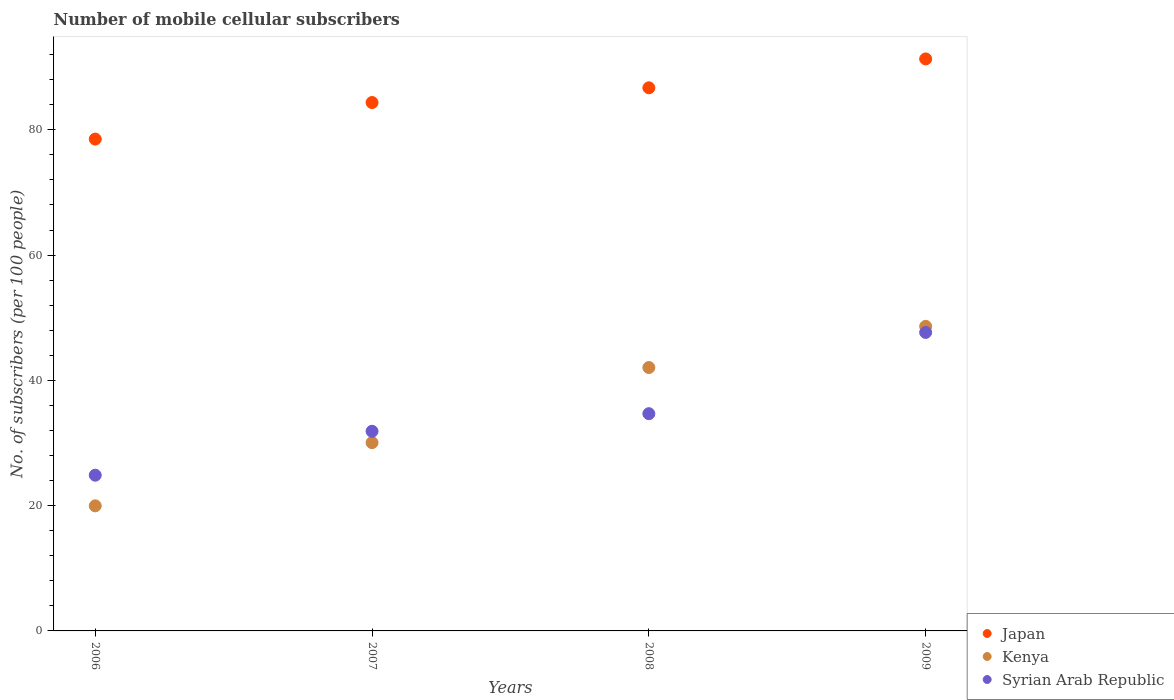Is the number of dotlines equal to the number of legend labels?
Make the answer very short. Yes. What is the number of mobile cellular subscribers in Syrian Arab Republic in 2007?
Make the answer very short. 31.87. Across all years, what is the maximum number of mobile cellular subscribers in Kenya?
Your response must be concise. 48.62. Across all years, what is the minimum number of mobile cellular subscribers in Syrian Arab Republic?
Ensure brevity in your answer.  24.86. In which year was the number of mobile cellular subscribers in Syrian Arab Republic maximum?
Your response must be concise. 2009. What is the total number of mobile cellular subscribers in Kenya in the graph?
Your answer should be compact. 140.71. What is the difference between the number of mobile cellular subscribers in Syrian Arab Republic in 2008 and that in 2009?
Your response must be concise. -12.97. What is the difference between the number of mobile cellular subscribers in Kenya in 2007 and the number of mobile cellular subscribers in Syrian Arab Republic in 2008?
Your answer should be compact. -4.62. What is the average number of mobile cellular subscribers in Japan per year?
Offer a very short reply. 85.22. In the year 2006, what is the difference between the number of mobile cellular subscribers in Kenya and number of mobile cellular subscribers in Japan?
Offer a very short reply. -58.55. What is the ratio of the number of mobile cellular subscribers in Kenya in 2006 to that in 2009?
Provide a short and direct response. 0.41. What is the difference between the highest and the second highest number of mobile cellular subscribers in Kenya?
Your answer should be compact. 6.58. What is the difference between the highest and the lowest number of mobile cellular subscribers in Japan?
Provide a short and direct response. 12.8. Is the sum of the number of mobile cellular subscribers in Kenya in 2006 and 2007 greater than the maximum number of mobile cellular subscribers in Syrian Arab Republic across all years?
Your answer should be compact. Yes. Is the number of mobile cellular subscribers in Syrian Arab Republic strictly greater than the number of mobile cellular subscribers in Kenya over the years?
Ensure brevity in your answer.  No. Is the number of mobile cellular subscribers in Japan strictly less than the number of mobile cellular subscribers in Syrian Arab Republic over the years?
Provide a short and direct response. No. How many dotlines are there?
Ensure brevity in your answer.  3. What is the difference between two consecutive major ticks on the Y-axis?
Give a very brief answer. 20. Are the values on the major ticks of Y-axis written in scientific E-notation?
Provide a succinct answer. No. Does the graph contain any zero values?
Keep it short and to the point. No. Does the graph contain grids?
Your answer should be very brief. No. Where does the legend appear in the graph?
Your answer should be very brief. Bottom right. What is the title of the graph?
Make the answer very short. Number of mobile cellular subscribers. What is the label or title of the Y-axis?
Keep it short and to the point. No. of subscribers (per 100 people). What is the No. of subscribers (per 100 people) of Japan in 2006?
Provide a succinct answer. 78.52. What is the No. of subscribers (per 100 people) of Kenya in 2006?
Ensure brevity in your answer.  19.97. What is the No. of subscribers (per 100 people) in Syrian Arab Republic in 2006?
Make the answer very short. 24.86. What is the No. of subscribers (per 100 people) in Japan in 2007?
Your answer should be very brief. 84.35. What is the No. of subscribers (per 100 people) in Kenya in 2007?
Offer a very short reply. 30.06. What is the No. of subscribers (per 100 people) in Syrian Arab Republic in 2007?
Your response must be concise. 31.87. What is the No. of subscribers (per 100 people) in Japan in 2008?
Offer a very short reply. 86.71. What is the No. of subscribers (per 100 people) in Kenya in 2008?
Provide a short and direct response. 42.05. What is the No. of subscribers (per 100 people) in Syrian Arab Republic in 2008?
Provide a succinct answer. 34.68. What is the No. of subscribers (per 100 people) of Japan in 2009?
Keep it short and to the point. 91.32. What is the No. of subscribers (per 100 people) of Kenya in 2009?
Give a very brief answer. 48.62. What is the No. of subscribers (per 100 people) of Syrian Arab Republic in 2009?
Your response must be concise. 47.65. Across all years, what is the maximum No. of subscribers (per 100 people) in Japan?
Offer a terse response. 91.32. Across all years, what is the maximum No. of subscribers (per 100 people) in Kenya?
Your answer should be very brief. 48.62. Across all years, what is the maximum No. of subscribers (per 100 people) of Syrian Arab Republic?
Keep it short and to the point. 47.65. Across all years, what is the minimum No. of subscribers (per 100 people) of Japan?
Make the answer very short. 78.52. Across all years, what is the minimum No. of subscribers (per 100 people) of Kenya?
Your answer should be very brief. 19.97. Across all years, what is the minimum No. of subscribers (per 100 people) of Syrian Arab Republic?
Your answer should be compact. 24.86. What is the total No. of subscribers (per 100 people) in Japan in the graph?
Your response must be concise. 340.9. What is the total No. of subscribers (per 100 people) of Kenya in the graph?
Ensure brevity in your answer.  140.71. What is the total No. of subscribers (per 100 people) of Syrian Arab Republic in the graph?
Ensure brevity in your answer.  139.07. What is the difference between the No. of subscribers (per 100 people) in Japan in 2006 and that in 2007?
Your answer should be very brief. -5.83. What is the difference between the No. of subscribers (per 100 people) of Kenya in 2006 and that in 2007?
Ensure brevity in your answer.  -10.09. What is the difference between the No. of subscribers (per 100 people) of Syrian Arab Republic in 2006 and that in 2007?
Keep it short and to the point. -7.01. What is the difference between the No. of subscribers (per 100 people) of Japan in 2006 and that in 2008?
Ensure brevity in your answer.  -8.19. What is the difference between the No. of subscribers (per 100 people) of Kenya in 2006 and that in 2008?
Keep it short and to the point. -22.08. What is the difference between the No. of subscribers (per 100 people) in Syrian Arab Republic in 2006 and that in 2008?
Your answer should be compact. -9.82. What is the difference between the No. of subscribers (per 100 people) in Japan in 2006 and that in 2009?
Offer a terse response. -12.8. What is the difference between the No. of subscribers (per 100 people) in Kenya in 2006 and that in 2009?
Give a very brief answer. -28.65. What is the difference between the No. of subscribers (per 100 people) of Syrian Arab Republic in 2006 and that in 2009?
Provide a succinct answer. -22.79. What is the difference between the No. of subscribers (per 100 people) in Japan in 2007 and that in 2008?
Give a very brief answer. -2.35. What is the difference between the No. of subscribers (per 100 people) of Kenya in 2007 and that in 2008?
Your answer should be compact. -11.99. What is the difference between the No. of subscribers (per 100 people) in Syrian Arab Republic in 2007 and that in 2008?
Ensure brevity in your answer.  -2.81. What is the difference between the No. of subscribers (per 100 people) in Japan in 2007 and that in 2009?
Your answer should be very brief. -6.96. What is the difference between the No. of subscribers (per 100 people) in Kenya in 2007 and that in 2009?
Make the answer very short. -18.56. What is the difference between the No. of subscribers (per 100 people) in Syrian Arab Republic in 2007 and that in 2009?
Keep it short and to the point. -15.78. What is the difference between the No. of subscribers (per 100 people) in Japan in 2008 and that in 2009?
Offer a very short reply. -4.61. What is the difference between the No. of subscribers (per 100 people) in Kenya in 2008 and that in 2009?
Provide a short and direct response. -6.58. What is the difference between the No. of subscribers (per 100 people) of Syrian Arab Republic in 2008 and that in 2009?
Your response must be concise. -12.97. What is the difference between the No. of subscribers (per 100 people) in Japan in 2006 and the No. of subscribers (per 100 people) in Kenya in 2007?
Offer a very short reply. 48.46. What is the difference between the No. of subscribers (per 100 people) of Japan in 2006 and the No. of subscribers (per 100 people) of Syrian Arab Republic in 2007?
Keep it short and to the point. 46.65. What is the difference between the No. of subscribers (per 100 people) in Kenya in 2006 and the No. of subscribers (per 100 people) in Syrian Arab Republic in 2007?
Make the answer very short. -11.9. What is the difference between the No. of subscribers (per 100 people) in Japan in 2006 and the No. of subscribers (per 100 people) in Kenya in 2008?
Provide a short and direct response. 36.47. What is the difference between the No. of subscribers (per 100 people) of Japan in 2006 and the No. of subscribers (per 100 people) of Syrian Arab Republic in 2008?
Your answer should be compact. 43.84. What is the difference between the No. of subscribers (per 100 people) of Kenya in 2006 and the No. of subscribers (per 100 people) of Syrian Arab Republic in 2008?
Give a very brief answer. -14.71. What is the difference between the No. of subscribers (per 100 people) of Japan in 2006 and the No. of subscribers (per 100 people) of Kenya in 2009?
Provide a succinct answer. 29.89. What is the difference between the No. of subscribers (per 100 people) in Japan in 2006 and the No. of subscribers (per 100 people) in Syrian Arab Republic in 2009?
Keep it short and to the point. 30.87. What is the difference between the No. of subscribers (per 100 people) in Kenya in 2006 and the No. of subscribers (per 100 people) in Syrian Arab Republic in 2009?
Offer a very short reply. -27.68. What is the difference between the No. of subscribers (per 100 people) of Japan in 2007 and the No. of subscribers (per 100 people) of Kenya in 2008?
Offer a very short reply. 42.31. What is the difference between the No. of subscribers (per 100 people) of Japan in 2007 and the No. of subscribers (per 100 people) of Syrian Arab Republic in 2008?
Provide a succinct answer. 49.67. What is the difference between the No. of subscribers (per 100 people) in Kenya in 2007 and the No. of subscribers (per 100 people) in Syrian Arab Republic in 2008?
Offer a very short reply. -4.62. What is the difference between the No. of subscribers (per 100 people) in Japan in 2007 and the No. of subscribers (per 100 people) in Kenya in 2009?
Make the answer very short. 35.73. What is the difference between the No. of subscribers (per 100 people) of Japan in 2007 and the No. of subscribers (per 100 people) of Syrian Arab Republic in 2009?
Your response must be concise. 36.7. What is the difference between the No. of subscribers (per 100 people) of Kenya in 2007 and the No. of subscribers (per 100 people) of Syrian Arab Republic in 2009?
Offer a terse response. -17.59. What is the difference between the No. of subscribers (per 100 people) in Japan in 2008 and the No. of subscribers (per 100 people) in Kenya in 2009?
Your answer should be very brief. 38.08. What is the difference between the No. of subscribers (per 100 people) of Japan in 2008 and the No. of subscribers (per 100 people) of Syrian Arab Republic in 2009?
Give a very brief answer. 39.06. What is the difference between the No. of subscribers (per 100 people) in Kenya in 2008 and the No. of subscribers (per 100 people) in Syrian Arab Republic in 2009?
Your answer should be very brief. -5.6. What is the average No. of subscribers (per 100 people) in Japan per year?
Provide a succinct answer. 85.22. What is the average No. of subscribers (per 100 people) in Kenya per year?
Your answer should be compact. 35.18. What is the average No. of subscribers (per 100 people) in Syrian Arab Republic per year?
Provide a succinct answer. 34.77. In the year 2006, what is the difference between the No. of subscribers (per 100 people) of Japan and No. of subscribers (per 100 people) of Kenya?
Give a very brief answer. 58.55. In the year 2006, what is the difference between the No. of subscribers (per 100 people) in Japan and No. of subscribers (per 100 people) in Syrian Arab Republic?
Your answer should be very brief. 53.66. In the year 2006, what is the difference between the No. of subscribers (per 100 people) in Kenya and No. of subscribers (per 100 people) in Syrian Arab Republic?
Your answer should be very brief. -4.89. In the year 2007, what is the difference between the No. of subscribers (per 100 people) of Japan and No. of subscribers (per 100 people) of Kenya?
Your response must be concise. 54.29. In the year 2007, what is the difference between the No. of subscribers (per 100 people) in Japan and No. of subscribers (per 100 people) in Syrian Arab Republic?
Give a very brief answer. 52.48. In the year 2007, what is the difference between the No. of subscribers (per 100 people) of Kenya and No. of subscribers (per 100 people) of Syrian Arab Republic?
Offer a very short reply. -1.81. In the year 2008, what is the difference between the No. of subscribers (per 100 people) of Japan and No. of subscribers (per 100 people) of Kenya?
Your response must be concise. 44.66. In the year 2008, what is the difference between the No. of subscribers (per 100 people) of Japan and No. of subscribers (per 100 people) of Syrian Arab Republic?
Your response must be concise. 52.03. In the year 2008, what is the difference between the No. of subscribers (per 100 people) of Kenya and No. of subscribers (per 100 people) of Syrian Arab Republic?
Provide a short and direct response. 7.37. In the year 2009, what is the difference between the No. of subscribers (per 100 people) of Japan and No. of subscribers (per 100 people) of Kenya?
Offer a very short reply. 42.69. In the year 2009, what is the difference between the No. of subscribers (per 100 people) of Japan and No. of subscribers (per 100 people) of Syrian Arab Republic?
Offer a very short reply. 43.67. In the year 2009, what is the difference between the No. of subscribers (per 100 people) in Kenya and No. of subscribers (per 100 people) in Syrian Arab Republic?
Offer a very short reply. 0.97. What is the ratio of the No. of subscribers (per 100 people) of Japan in 2006 to that in 2007?
Your answer should be very brief. 0.93. What is the ratio of the No. of subscribers (per 100 people) in Kenya in 2006 to that in 2007?
Make the answer very short. 0.66. What is the ratio of the No. of subscribers (per 100 people) in Syrian Arab Republic in 2006 to that in 2007?
Offer a very short reply. 0.78. What is the ratio of the No. of subscribers (per 100 people) in Japan in 2006 to that in 2008?
Give a very brief answer. 0.91. What is the ratio of the No. of subscribers (per 100 people) of Kenya in 2006 to that in 2008?
Keep it short and to the point. 0.47. What is the ratio of the No. of subscribers (per 100 people) in Syrian Arab Republic in 2006 to that in 2008?
Your answer should be very brief. 0.72. What is the ratio of the No. of subscribers (per 100 people) in Japan in 2006 to that in 2009?
Offer a terse response. 0.86. What is the ratio of the No. of subscribers (per 100 people) in Kenya in 2006 to that in 2009?
Keep it short and to the point. 0.41. What is the ratio of the No. of subscribers (per 100 people) in Syrian Arab Republic in 2006 to that in 2009?
Provide a succinct answer. 0.52. What is the ratio of the No. of subscribers (per 100 people) in Japan in 2007 to that in 2008?
Offer a terse response. 0.97. What is the ratio of the No. of subscribers (per 100 people) in Kenya in 2007 to that in 2008?
Ensure brevity in your answer.  0.71. What is the ratio of the No. of subscribers (per 100 people) in Syrian Arab Republic in 2007 to that in 2008?
Give a very brief answer. 0.92. What is the ratio of the No. of subscribers (per 100 people) in Japan in 2007 to that in 2009?
Your answer should be compact. 0.92. What is the ratio of the No. of subscribers (per 100 people) in Kenya in 2007 to that in 2009?
Your response must be concise. 0.62. What is the ratio of the No. of subscribers (per 100 people) in Syrian Arab Republic in 2007 to that in 2009?
Provide a short and direct response. 0.67. What is the ratio of the No. of subscribers (per 100 people) in Japan in 2008 to that in 2009?
Your answer should be compact. 0.95. What is the ratio of the No. of subscribers (per 100 people) of Kenya in 2008 to that in 2009?
Offer a very short reply. 0.86. What is the ratio of the No. of subscribers (per 100 people) in Syrian Arab Republic in 2008 to that in 2009?
Your answer should be very brief. 0.73. What is the difference between the highest and the second highest No. of subscribers (per 100 people) of Japan?
Ensure brevity in your answer.  4.61. What is the difference between the highest and the second highest No. of subscribers (per 100 people) in Kenya?
Give a very brief answer. 6.58. What is the difference between the highest and the second highest No. of subscribers (per 100 people) in Syrian Arab Republic?
Ensure brevity in your answer.  12.97. What is the difference between the highest and the lowest No. of subscribers (per 100 people) in Japan?
Provide a succinct answer. 12.8. What is the difference between the highest and the lowest No. of subscribers (per 100 people) in Kenya?
Offer a very short reply. 28.65. What is the difference between the highest and the lowest No. of subscribers (per 100 people) in Syrian Arab Republic?
Provide a succinct answer. 22.79. 